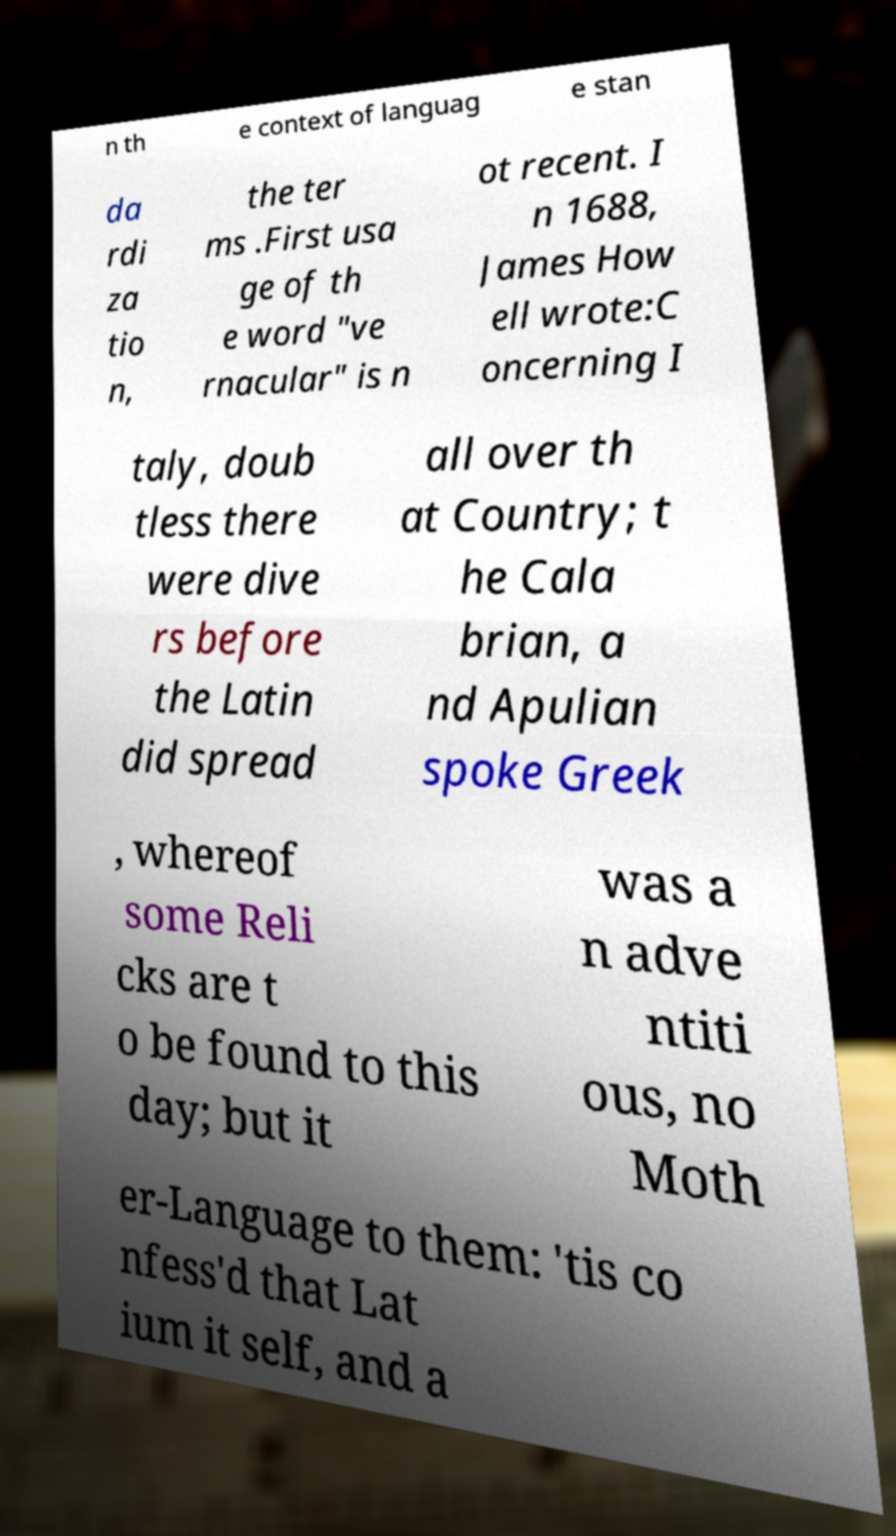Can you read and provide the text displayed in the image?This photo seems to have some interesting text. Can you extract and type it out for me? n th e context of languag e stan da rdi za tio n, the ter ms .First usa ge of th e word "ve rnacular" is n ot recent. I n 1688, James How ell wrote:C oncerning I taly, doub tless there were dive rs before the Latin did spread all over th at Country; t he Cala brian, a nd Apulian spoke Greek , whereof some Reli cks are t o be found to this day; but it was a n adve ntiti ous, no Moth er-Language to them: 'tis co nfess'd that Lat ium it self, and a 